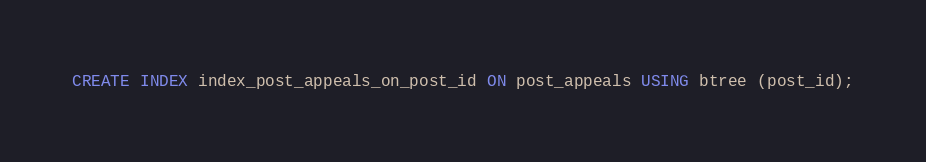<code> <loc_0><loc_0><loc_500><loc_500><_SQL_>CREATE INDEX index_post_appeals_on_post_id ON post_appeals USING btree (post_id);</code> 